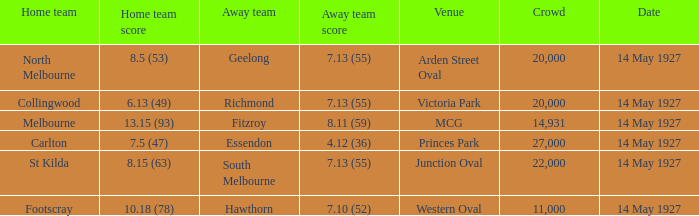Which away team had a score of 4.12 (36)? Essendon. 